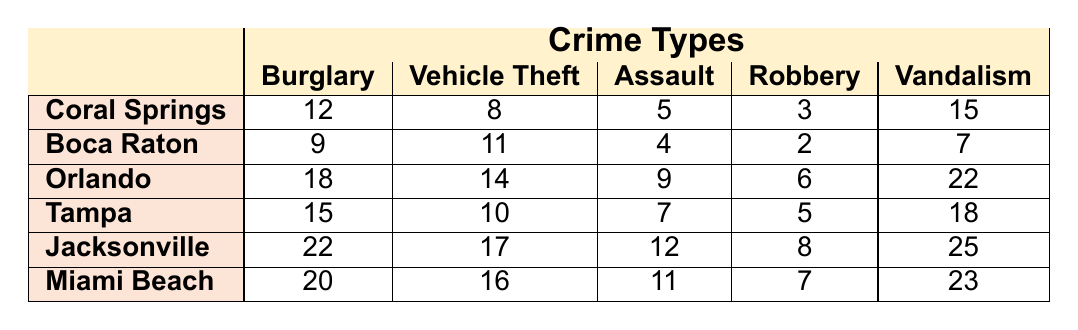What neighborhood has the highest number of burglaries? In the table, the values for burglaries are listed for each neighborhood. Coral Springs has 12, Boca Raton has 9, Orlando has 18, Tampa has 15, Jacksonville has 22, and Miami Beach has 20. The highest value is 22 in Jacksonville.
Answer: Jacksonville What is the total number of vehicle thefts reported in all neighborhoods combined? To find the total number of vehicle thefts, we sum the vehicle theft values for each neighborhood: 8 (Coral Springs) + 11 (Boca Raton) + 14 (Orlando) + 10 (Tampa) + 17 (Jacksonville) + 16 (Miami Beach) = 76.
Answer: 76 Which neighborhood has the lowest number of assaults? The table presents the assault rates for each neighborhood: 5 for Coral Springs, 4 for Boca Raton, 9 for Orlando, 7 for Tampa, 12 for Jacksonville, and 11 for Miami Beach. The lowest is 4 in Boca Raton.
Answer: Boca Raton How many more instances of vandalism were reported in Miami Beach than in Boca Raton? The vandalism numbers are 15 for Coral Springs, 7 for Boca Raton, and 23 for Miami Beach. The difference is 23 (Miami Beach) - 7 (Boca Raton) = 16.
Answer: 16 What is the average number of robberies across all neighborhoods? First, we add the robbery values: 3 (Coral Springs) + 2 (Boca Raton) + 6 (Orlando) + 5 (Tampa) + 8 (Jacksonville) + 7 (Miami Beach) = 31. There are 6 neighborhoods, so the average is 31 / 6 = 5.17.
Answer: 5.17 Is it true that Orlando has more burglaries than Tampa? From the table, Coral Springs has 12 burglaries, Boca Raton has 9, Orlando has 18, and Tampa has 15. Since 18 (Orlando) is greater than 15 (Tampa), the statement is true.
Answer: Yes Which crime type has the highest total across all neighborhoods? We need to sum the values for each crime type. Burglary total = 12 + 9 + 18 + 15 + 22 + 20 = 96, Vehicle Theft total = 8 + 11 + 14 + 10 + 17 + 16 = 76, Assault total = 5 + 4 + 9 + 7 + 12 + 11 = 48, Robbery total = 3 + 2 + 6 + 5 + 8 + 7 = 31, Vandalism total = 15 + 7 + 22 + 18 + 25 + 23 = 110. Vandalism has the highest total of 110.
Answer: Vandalism What is the difference between the maximum and minimum number of assaults reported in the neighborhoods? The maximum assault is 12 (Jacksonville) and the minimum is 4 (Boca Raton). The difference is 12 - 4 = 8.
Answer: 8 Which neighborhood has the highest total crime counts (sum of all crime types)? The total crime counts per neighborhood are: Coral Springs = 12 + 8 + 5 + 3 + 15 = 43, Boca Raton = 9 + 11 + 4 + 2 + 7 = 33, Orlando = 18 + 14 + 9 + 6 + 22 = 69, Tampa = 15 + 10 + 7 + 5 + 18 = 55, Jacksonville = 22 + 17 + 12 + 8 + 25 = 84, Miami Beach = 20 + 16 + 11 + 7 + 23 = 77. The highest total is 84 in Jacksonville.
Answer: Jacksonville 